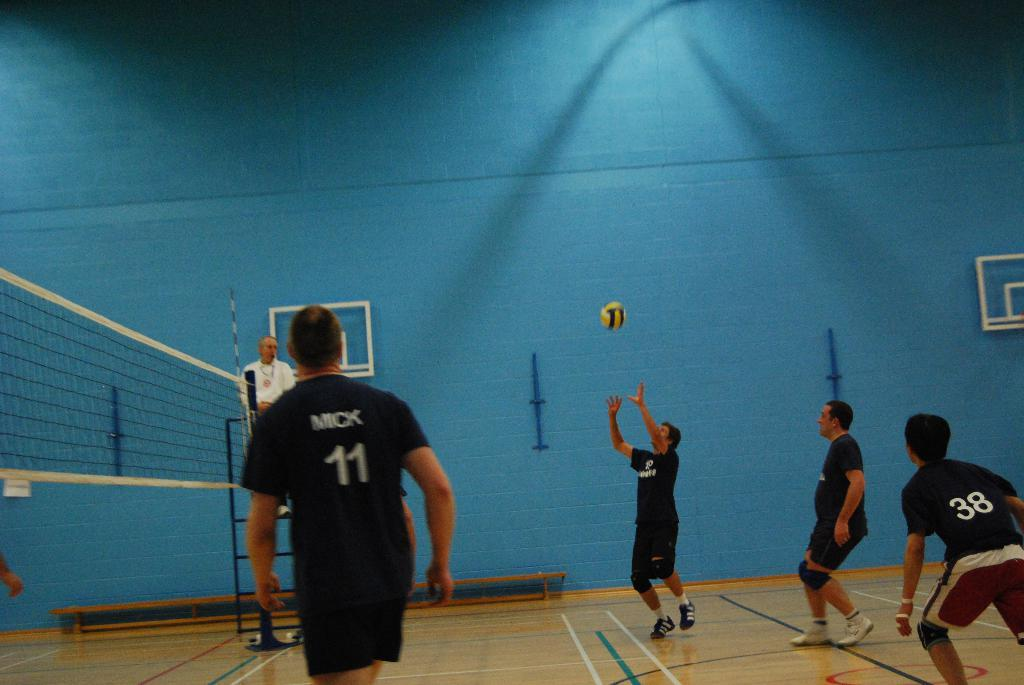Provide a one-sentence caption for the provided image. Mick 11 waits for the ball to come his way. 